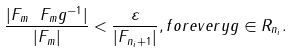<formula> <loc_0><loc_0><loc_500><loc_500>\frac { | F _ { m } \ F _ { m } g ^ { - 1 } | } { | F _ { m } | } < \frac { \varepsilon } { | F _ { n _ { i } + 1 } | } , f o r e v e r y g \in R _ { n _ { i } } .</formula> 